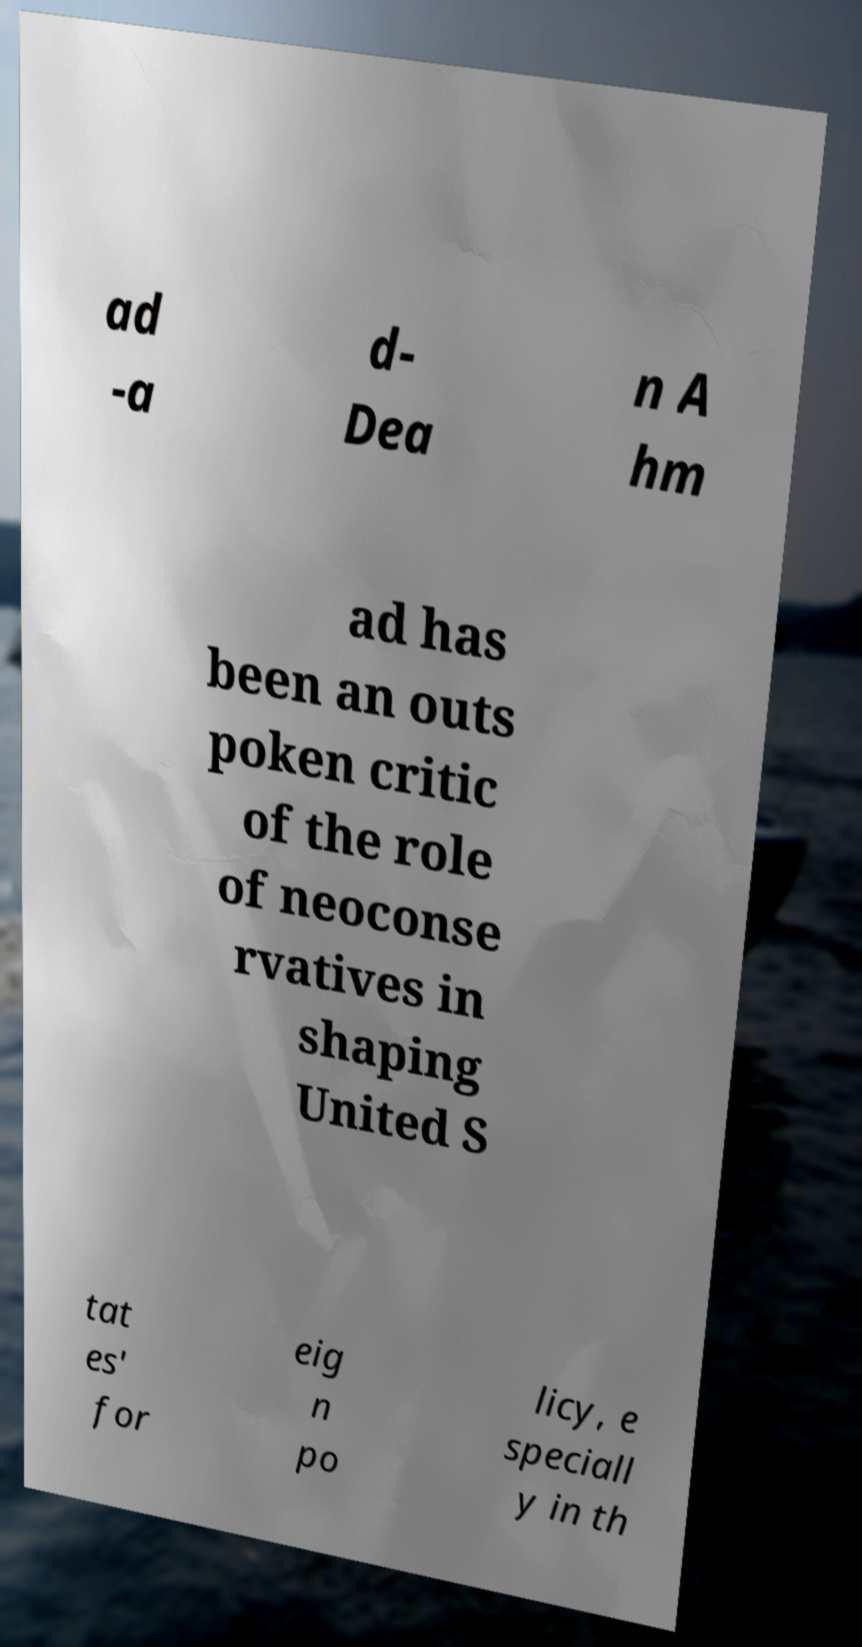I need the written content from this picture converted into text. Can you do that? ad -a d- Dea n A hm ad has been an outs poken critic of the role of neoconse rvatives in shaping United S tat es' for eig n po licy, e speciall y in th 